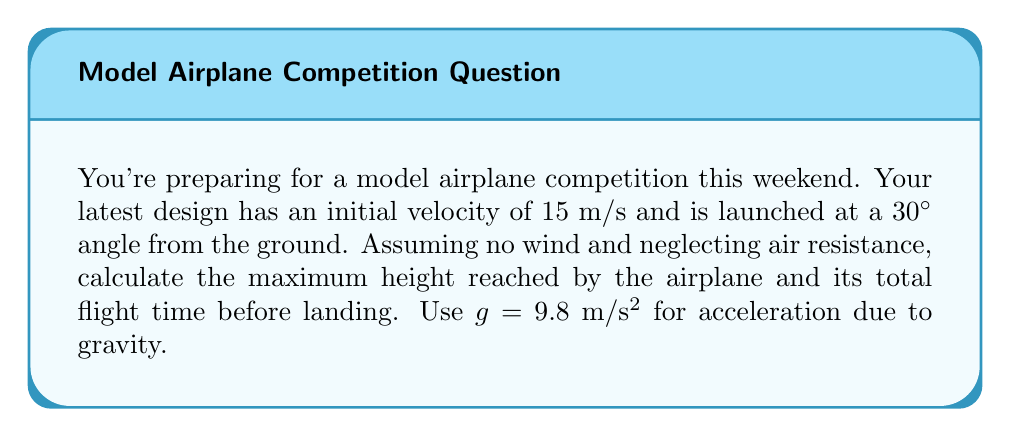Solve this math problem. Let's approach this step-by-step using projectile motion equations:

1) First, let's break down the initial velocity into its x and y components:
   $v_{0x} = v_0 \cos \theta = 15 \cos 30° = 12.99 \text{ m/s}$
   $v_{0y} = v_0 \sin \theta = 15 \sin 30° = 7.5 \text{ m/s}$

2) To find the maximum height, we use the equation:
   $h_{max} = \frac{v_{0y}^2}{2g}$
   $h_{max} = \frac{(7.5 \text{ m/s})^2}{2(9.8 \text{ m/s}^2)} = 2.87 \text{ m}$

3) For the total flight time, we need to calculate the time to reach the maximum height and double it:
   Time to reach max height: $t_{up} = \frac{v_{0y}}{g} = \frac{7.5 \text{ m/s}}{9.8 \text{ m/s}^2} = 0.77 \text{ s}$
   Total flight time: $t_{total} = 2t_{up} = 2(0.77 \text{ s}) = 1.54 \text{ s}$

4) We can verify this using the equation for vertical displacement:
   $y = v_{0y}t - \frac{1}{2}gt^2$
   At landing, y = 0:
   $0 = 7.5t - \frac{1}{2}(9.8)t^2$
   Solving this quadratic equation gives t = 1.54 s, confirming our result.
Answer: Maximum height: 2.87 m; Total flight time: 1.54 s 